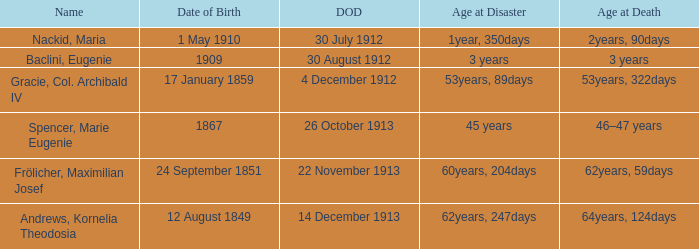When did the person born 24 September 1851 pass away? 22 November 1913. 